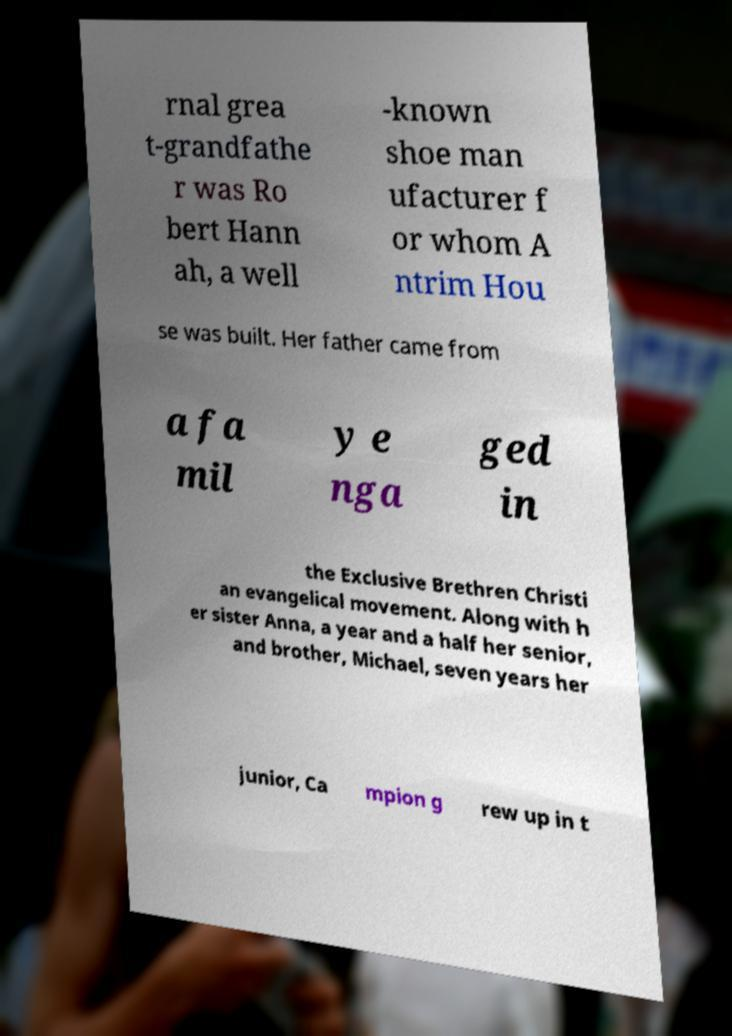Please identify and transcribe the text found in this image. rnal grea t-grandfathe r was Ro bert Hann ah, a well -known shoe man ufacturer f or whom A ntrim Hou se was built. Her father came from a fa mil y e nga ged in the Exclusive Brethren Christi an evangelical movement. Along with h er sister Anna, a year and a half her senior, and brother, Michael, seven years her junior, Ca mpion g rew up in t 